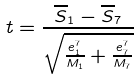<formula> <loc_0><loc_0><loc_500><loc_500>t = \frac { \overline { S } _ { 1 } - \overline { S } _ { 7 } } { \sqrt { \frac { e _ { 1 } ^ { 7 } } { M _ { 1 } } + \frac { e _ { 7 } ^ { 7 } } { M _ { 7 } } } }</formula> 